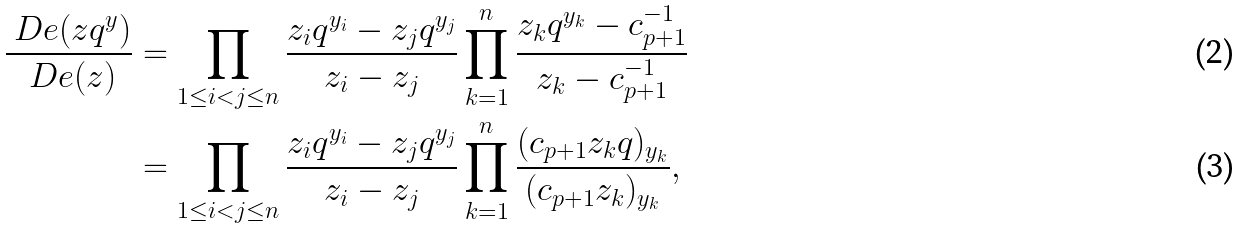<formula> <loc_0><loc_0><loc_500><loc_500>\frac { \ D e ( z q ^ { y } ) } { \ D e ( z ) } & = \prod _ { 1 \leq i < j \leq n } \frac { z _ { i } q ^ { y _ { i } } - z _ { j } q ^ { y _ { j } } } { z _ { i } - z _ { j } } \prod _ { k = 1 } ^ { n } \frac { z _ { k } q ^ { y _ { k } } - c _ { p + 1 } ^ { - 1 } } { z _ { k } - c _ { p + 1 } ^ { - 1 } } \\ & = \prod _ { 1 \leq i < j \leq n } \frac { z _ { i } q ^ { y _ { i } } - z _ { j } q ^ { y _ { j } } } { z _ { i } - z _ { j } } \prod _ { k = 1 } ^ { n } \frac { ( c _ { p + 1 } z _ { k } q ) _ { y _ { k } } } { ( c _ { p + 1 } z _ { k } ) _ { y _ { k } } } ,</formula> 